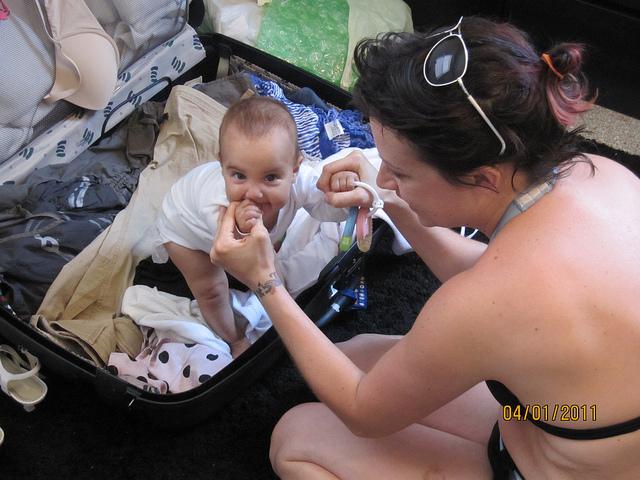Are the children in this picture standing?
Answer briefly. No. Where is the tattoo on the woman?
Short answer required. Wrist. What is the date that this picture was taken?
Be succinct. 04/01/2011. What is around the woman's neck?
Short answer required. Strap. What is the girl holding in her right hand?
Quick response, please. Baby hand. Does the woman probably have pierced ears?
Answer briefly. No. Is the woman wearing an evening dress?
Be succinct. No. What this person is doing?
Quick response, please. Playing with baby. Is the baby happy?
Keep it brief. Yes. What is the person to the left holding?
Quick response, please. Hands. 